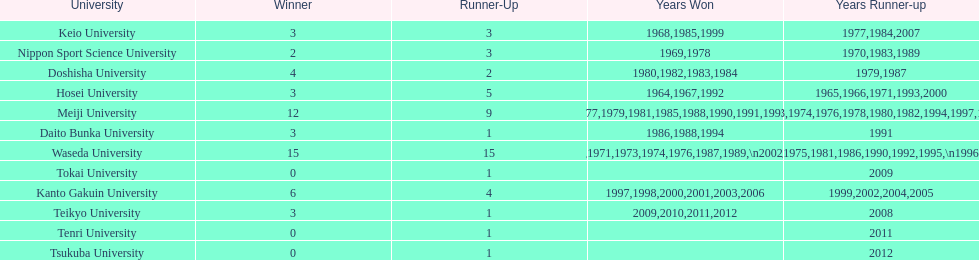Which university had the most years won? Waseda University. 